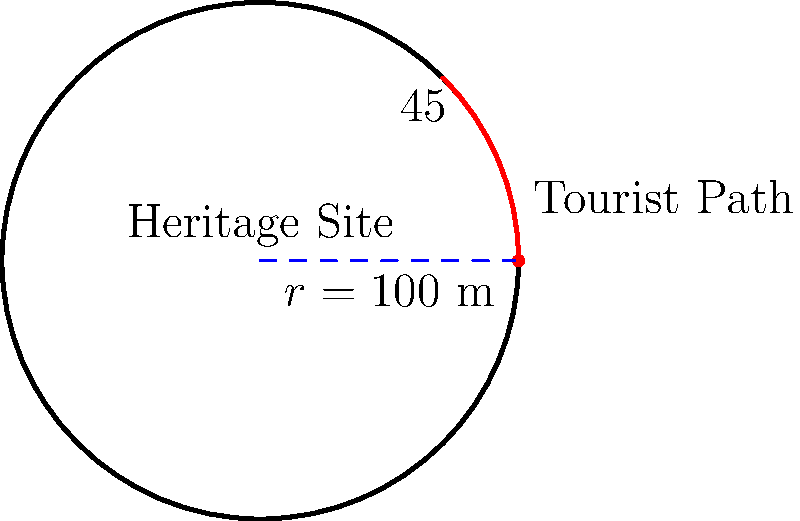A circular heritage site with a radius of 100 meters is experiencing increased tourist foot traffic. To preserve the site, authorities want to limit access to a quarter of the site's perimeter. If tourists are allowed to walk along an arc spanning a 45° angle from the site's center, what is the length of the accessible path in meters? To solve this problem, we need to use the formula for arc length in polar coordinates:

1) The formula for arc length is: $s = r\theta$
   Where $s$ is the arc length, $r$ is the radius, and $\theta$ is the angle in radians.

2) We are given the radius $r = 100$ meters and the angle $\theta = 45°$.

3) First, we need to convert 45° to radians:
   $45° \times \frac{\pi}{180°} = \frac{\pi}{4}$ radians

4) Now we can substitute these values into our formula:
   $s = 100 \times \frac{\pi}{4}$

5) Simplify:
   $s = 25\pi$ meters

Therefore, the length of the accessible path is $25\pi$ meters.
Answer: $25\pi$ meters 